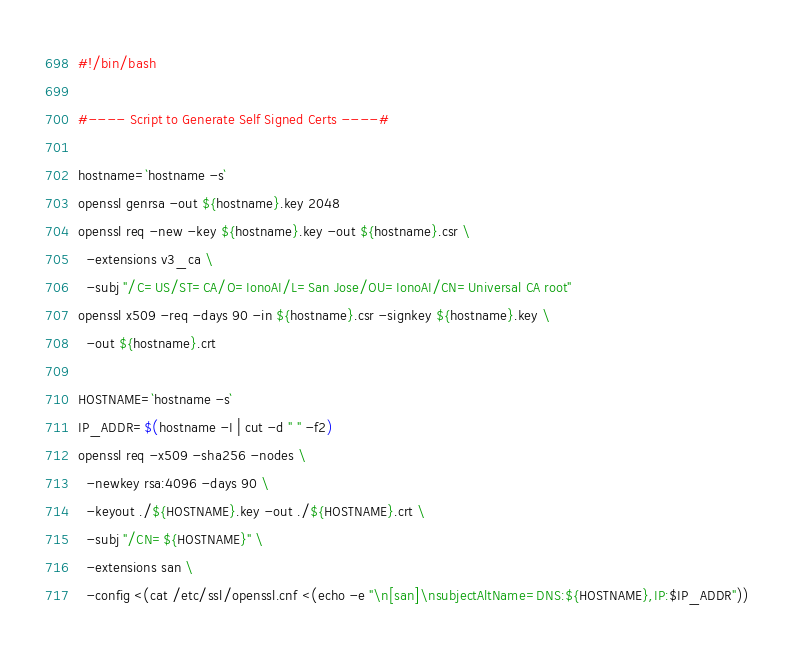Convert code to text. <code><loc_0><loc_0><loc_500><loc_500><_Bash_>#!/bin/bash

#---- Script to Generate Self Signed Certs ----#

hostname=`hostname -s`
openssl genrsa -out ${hostname}.key 2048
openssl req -new -key ${hostname}.key -out ${hostname}.csr \
  -extensions v3_ca \
  -subj "/C=US/ST=CA/O=IonoAI/L=San Jose/OU=IonoAI/CN=Universal CA root"
openssl x509 -req -days 90 -in ${hostname}.csr -signkey ${hostname}.key \
  -out ${hostname}.crt

HOSTNAME=`hostname -s`
IP_ADDR=$(hostname -I | cut -d " " -f2)
openssl req -x509 -sha256 -nodes \
  -newkey rsa:4096 -days 90 \
  -keyout ./${HOSTNAME}.key -out ./${HOSTNAME}.crt \
  -subj "/CN=${HOSTNAME}" \
  -extensions san \
  -config <(cat /etc/ssl/openssl.cnf <(echo -e "\n[san]\nsubjectAltName=DNS:${HOSTNAME},IP:$IP_ADDR"))

</code> 